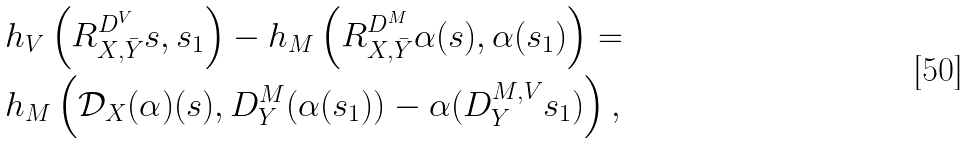Convert formula to latex. <formula><loc_0><loc_0><loc_500><loc_500>& h _ { V } \left ( R ^ { D ^ { V } } _ { X , \bar { Y } } s , s _ { 1 } \right ) - h _ { M } \left ( R ^ { D ^ { M } } _ { X , \bar { Y } } \alpha ( s ) , \alpha ( s _ { 1 } ) \right ) = \\ & h _ { M } \left ( { \mathcal { D } } _ { X } ( \alpha ) ( s ) , D ^ { M } _ { Y } ( \alpha ( s _ { 1 } ) ) - \alpha ( D ^ { M , V } _ { Y } s _ { 1 } ) \right ) ,</formula> 